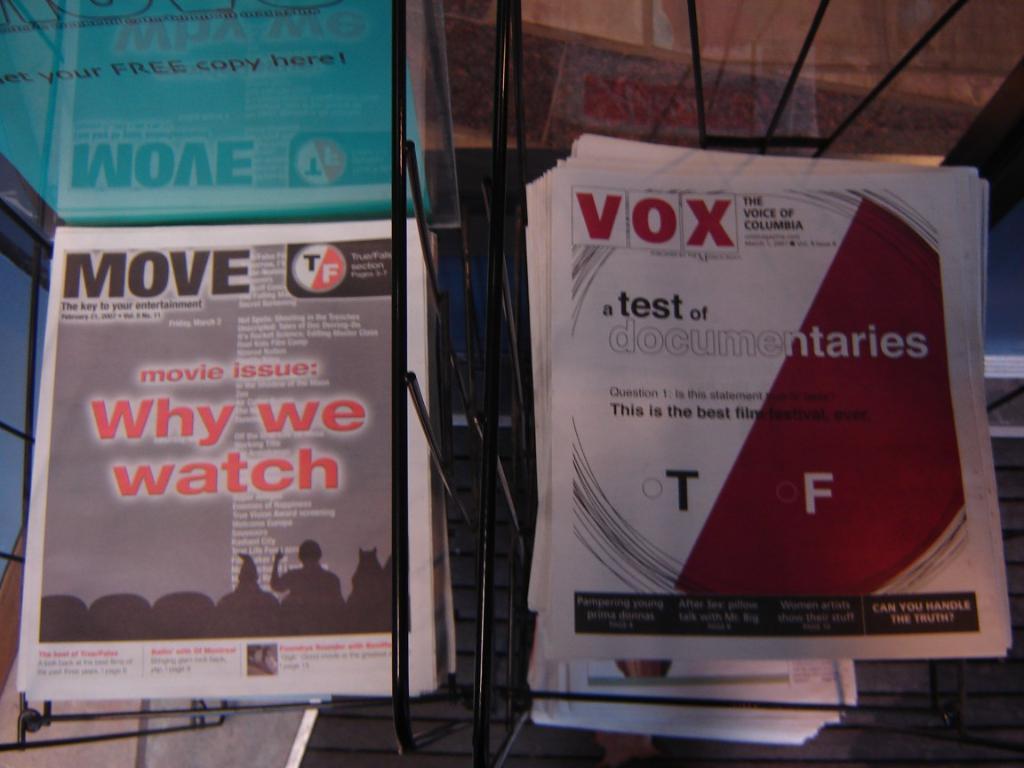What issue of magazine is on the left?
Give a very brief answer. Move. This is the book?
Provide a succinct answer. No. 